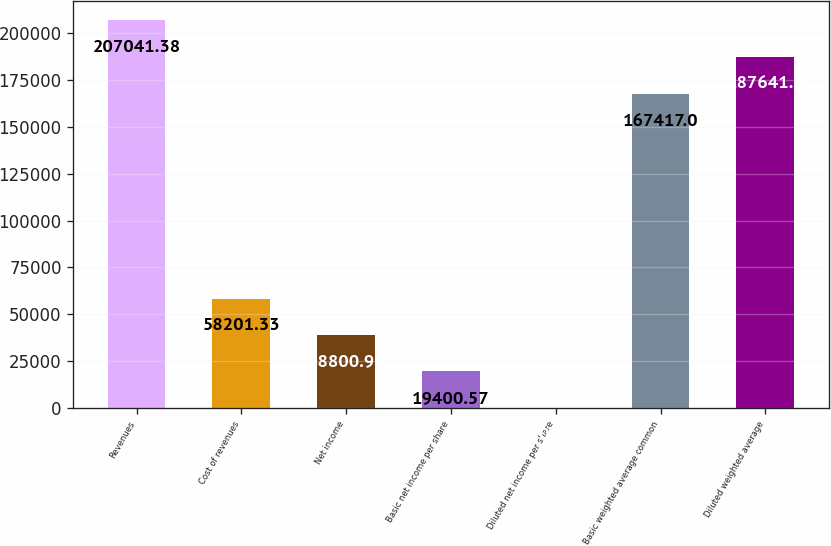<chart> <loc_0><loc_0><loc_500><loc_500><bar_chart><fcel>Revenues<fcel>Cost of revenues<fcel>Net income<fcel>Basic net income per share<fcel>Diluted net income per share<fcel>Basic weighted average common<fcel>Diluted weighted average<nl><fcel>207041<fcel>58201.3<fcel>38800.9<fcel>19400.6<fcel>0.19<fcel>167417<fcel>187641<nl></chart> 